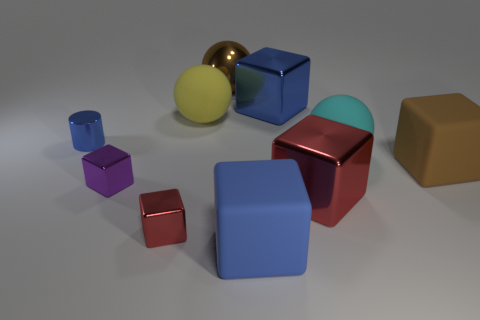There is a large matte cube that is in front of the brown thing in front of the large brown metallic ball; what is its color?
Make the answer very short. Blue. What is the size of the blue metal thing on the right side of the brown ball?
Make the answer very short. Large. Are there any tiny cylinders that have the same material as the large brown ball?
Your answer should be very brief. Yes. What number of small shiny objects have the same shape as the big red thing?
Your answer should be very brief. 2. There is a matte thing that is behind the tiny blue thing that is behind the red thing that is left of the yellow rubber sphere; what shape is it?
Offer a terse response. Sphere. What is the material of the blue object that is both right of the small purple metallic object and behind the purple object?
Make the answer very short. Metal. Does the blue shiny thing that is on the right side of the purple thing have the same size as the big brown sphere?
Keep it short and to the point. Yes. Are there more small purple things in front of the big cyan sphere than small red metallic things behind the large red metal block?
Ensure brevity in your answer.  Yes. There is a shiny thing that is on the right side of the large blue cube that is behind the red block that is left of the blue rubber thing; what is its color?
Ensure brevity in your answer.  Red. Do the cube that is behind the tiny blue object and the metallic cylinder have the same color?
Provide a short and direct response. Yes. 